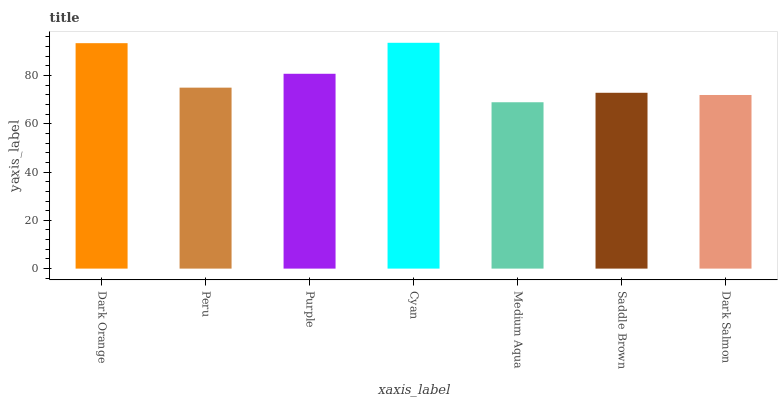Is Medium Aqua the minimum?
Answer yes or no. Yes. Is Cyan the maximum?
Answer yes or no. Yes. Is Peru the minimum?
Answer yes or no. No. Is Peru the maximum?
Answer yes or no. No. Is Dark Orange greater than Peru?
Answer yes or no. Yes. Is Peru less than Dark Orange?
Answer yes or no. Yes. Is Peru greater than Dark Orange?
Answer yes or no. No. Is Dark Orange less than Peru?
Answer yes or no. No. Is Peru the high median?
Answer yes or no. Yes. Is Peru the low median?
Answer yes or no. Yes. Is Saddle Brown the high median?
Answer yes or no. No. Is Dark Salmon the low median?
Answer yes or no. No. 